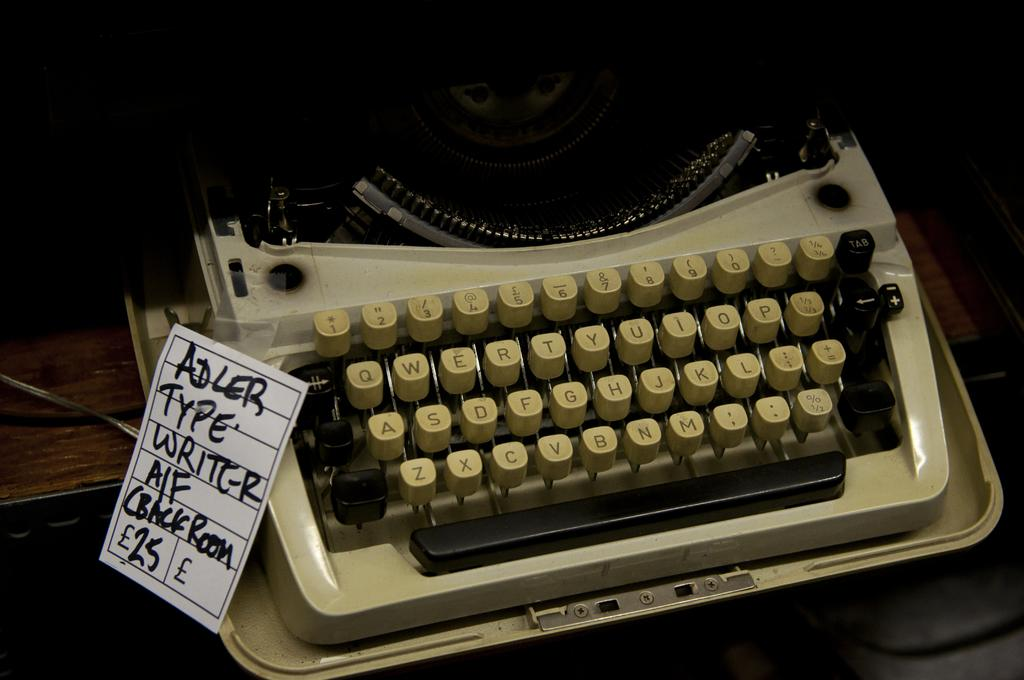Provide a one-sentence caption for the provided image. An old typewrite with a tag on it that says Adler Typewriter on it. 